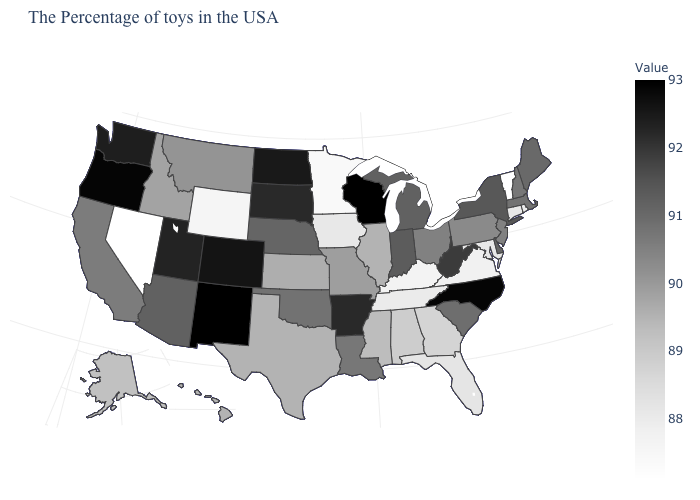Among the states that border Virginia , which have the lowest value?
Quick response, please. Kentucky. Does Louisiana have a lower value than Montana?
Give a very brief answer. No. Does Nevada have the lowest value in the USA?
Answer briefly. Yes. Does New Mexico have the highest value in the West?
Give a very brief answer. Yes. 